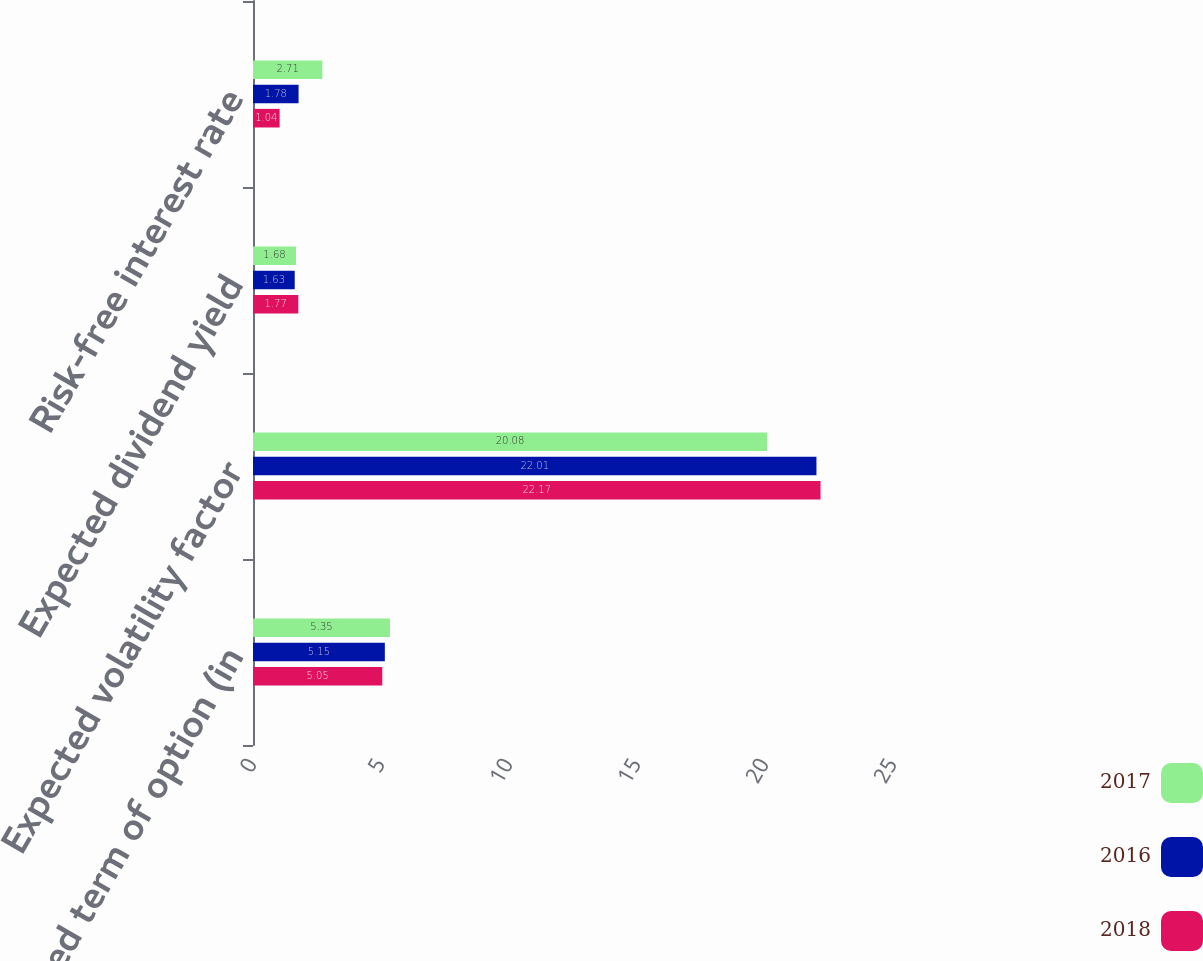Convert chart to OTSL. <chart><loc_0><loc_0><loc_500><loc_500><stacked_bar_chart><ecel><fcel>Expected term of option (in<fcel>Expected volatility factor<fcel>Expected dividend yield<fcel>Risk-free interest rate<nl><fcel>2017<fcel>5.35<fcel>20.08<fcel>1.68<fcel>2.71<nl><fcel>2016<fcel>5.15<fcel>22.01<fcel>1.63<fcel>1.78<nl><fcel>2018<fcel>5.05<fcel>22.17<fcel>1.77<fcel>1.04<nl></chart> 